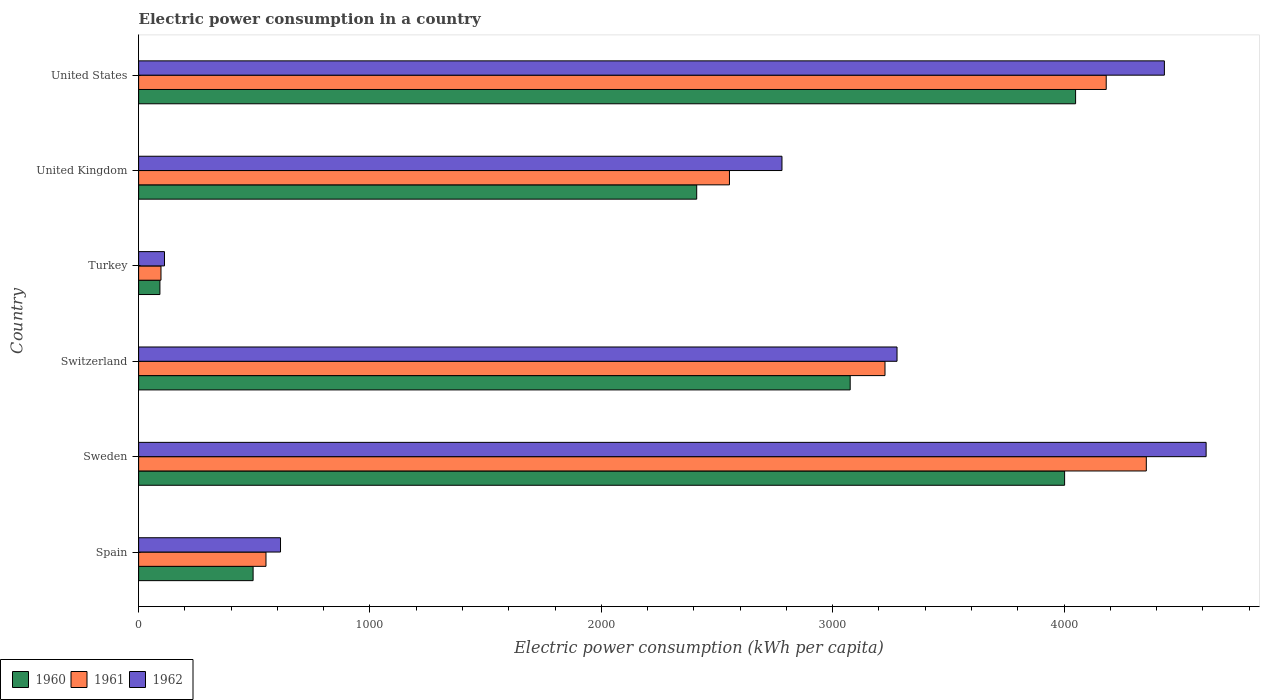How many different coloured bars are there?
Provide a succinct answer. 3. What is the electric power consumption in in 1960 in Sweden?
Give a very brief answer. 4002.32. Across all countries, what is the maximum electric power consumption in in 1961?
Your answer should be compact. 4355.45. Across all countries, what is the minimum electric power consumption in in 1961?
Give a very brief answer. 96.64. In which country was the electric power consumption in in 1962 maximum?
Your response must be concise. Sweden. In which country was the electric power consumption in in 1962 minimum?
Your answer should be compact. Turkey. What is the total electric power consumption in in 1961 in the graph?
Your answer should be very brief. 1.50e+04. What is the difference between the electric power consumption in in 1961 in Switzerland and that in United States?
Offer a very short reply. -956.18. What is the difference between the electric power consumption in in 1961 in Spain and the electric power consumption in in 1962 in Turkey?
Offer a terse response. 438.68. What is the average electric power consumption in in 1961 per country?
Your response must be concise. 2494.06. What is the difference between the electric power consumption in in 1960 and electric power consumption in in 1961 in Sweden?
Offer a very short reply. -353.13. In how many countries, is the electric power consumption in in 1960 greater than 600 kWh per capita?
Give a very brief answer. 4. What is the ratio of the electric power consumption in in 1960 in Sweden to that in United States?
Offer a terse response. 0.99. Is the electric power consumption in in 1961 in United Kingdom less than that in United States?
Your answer should be very brief. Yes. What is the difference between the highest and the second highest electric power consumption in in 1962?
Your answer should be very brief. 180.37. What is the difference between the highest and the lowest electric power consumption in in 1962?
Make the answer very short. 4502.22. In how many countries, is the electric power consumption in in 1961 greater than the average electric power consumption in in 1961 taken over all countries?
Provide a succinct answer. 4. What does the 2nd bar from the top in United States represents?
Give a very brief answer. 1961. Is it the case that in every country, the sum of the electric power consumption in in 1962 and electric power consumption in in 1961 is greater than the electric power consumption in in 1960?
Keep it short and to the point. Yes. Are all the bars in the graph horizontal?
Provide a short and direct response. Yes. Are the values on the major ticks of X-axis written in scientific E-notation?
Offer a very short reply. No. Where does the legend appear in the graph?
Ensure brevity in your answer.  Bottom left. How many legend labels are there?
Your answer should be compact. 3. How are the legend labels stacked?
Provide a short and direct response. Horizontal. What is the title of the graph?
Your answer should be very brief. Electric power consumption in a country. What is the label or title of the X-axis?
Offer a very short reply. Electric power consumption (kWh per capita). What is the label or title of the Y-axis?
Give a very brief answer. Country. What is the Electric power consumption (kWh per capita) in 1960 in Spain?
Provide a succinct answer. 494.8. What is the Electric power consumption (kWh per capita) of 1961 in Spain?
Your answer should be compact. 550.44. What is the Electric power consumption (kWh per capita) of 1962 in Spain?
Offer a very short reply. 613.25. What is the Electric power consumption (kWh per capita) in 1960 in Sweden?
Keep it short and to the point. 4002.32. What is the Electric power consumption (kWh per capita) in 1961 in Sweden?
Keep it short and to the point. 4355.45. What is the Electric power consumption (kWh per capita) of 1962 in Sweden?
Your answer should be compact. 4613.98. What is the Electric power consumption (kWh per capita) of 1960 in Switzerland?
Keep it short and to the point. 3075.55. What is the Electric power consumption (kWh per capita) in 1961 in Switzerland?
Your answer should be very brief. 3225.99. What is the Electric power consumption (kWh per capita) in 1962 in Switzerland?
Offer a terse response. 3278.01. What is the Electric power consumption (kWh per capita) of 1960 in Turkey?
Offer a terse response. 92.04. What is the Electric power consumption (kWh per capita) of 1961 in Turkey?
Ensure brevity in your answer.  96.64. What is the Electric power consumption (kWh per capita) in 1962 in Turkey?
Your answer should be compact. 111.76. What is the Electric power consumption (kWh per capita) of 1960 in United Kingdom?
Offer a terse response. 2412.14. What is the Electric power consumption (kWh per capita) in 1961 in United Kingdom?
Give a very brief answer. 2553.69. What is the Electric power consumption (kWh per capita) of 1962 in United Kingdom?
Make the answer very short. 2780.66. What is the Electric power consumption (kWh per capita) of 1960 in United States?
Offer a very short reply. 4049.79. What is the Electric power consumption (kWh per capita) in 1961 in United States?
Keep it short and to the point. 4182.18. What is the Electric power consumption (kWh per capita) of 1962 in United States?
Offer a terse response. 4433.61. Across all countries, what is the maximum Electric power consumption (kWh per capita) of 1960?
Make the answer very short. 4049.79. Across all countries, what is the maximum Electric power consumption (kWh per capita) of 1961?
Make the answer very short. 4355.45. Across all countries, what is the maximum Electric power consumption (kWh per capita) of 1962?
Offer a very short reply. 4613.98. Across all countries, what is the minimum Electric power consumption (kWh per capita) of 1960?
Give a very brief answer. 92.04. Across all countries, what is the minimum Electric power consumption (kWh per capita) in 1961?
Ensure brevity in your answer.  96.64. Across all countries, what is the minimum Electric power consumption (kWh per capita) in 1962?
Make the answer very short. 111.76. What is the total Electric power consumption (kWh per capita) of 1960 in the graph?
Your answer should be compact. 1.41e+04. What is the total Electric power consumption (kWh per capita) of 1961 in the graph?
Give a very brief answer. 1.50e+04. What is the total Electric power consumption (kWh per capita) in 1962 in the graph?
Your response must be concise. 1.58e+04. What is the difference between the Electric power consumption (kWh per capita) in 1960 in Spain and that in Sweden?
Offer a very short reply. -3507.53. What is the difference between the Electric power consumption (kWh per capita) in 1961 in Spain and that in Sweden?
Provide a succinct answer. -3805.02. What is the difference between the Electric power consumption (kWh per capita) in 1962 in Spain and that in Sweden?
Keep it short and to the point. -4000.73. What is the difference between the Electric power consumption (kWh per capita) of 1960 in Spain and that in Switzerland?
Your answer should be very brief. -2580.75. What is the difference between the Electric power consumption (kWh per capita) of 1961 in Spain and that in Switzerland?
Your answer should be very brief. -2675.56. What is the difference between the Electric power consumption (kWh per capita) in 1962 in Spain and that in Switzerland?
Your response must be concise. -2664.76. What is the difference between the Electric power consumption (kWh per capita) of 1960 in Spain and that in Turkey?
Make the answer very short. 402.76. What is the difference between the Electric power consumption (kWh per capita) of 1961 in Spain and that in Turkey?
Keep it short and to the point. 453.8. What is the difference between the Electric power consumption (kWh per capita) in 1962 in Spain and that in Turkey?
Your response must be concise. 501.49. What is the difference between the Electric power consumption (kWh per capita) in 1960 in Spain and that in United Kingdom?
Your answer should be compact. -1917.34. What is the difference between the Electric power consumption (kWh per capita) in 1961 in Spain and that in United Kingdom?
Your answer should be compact. -2003.26. What is the difference between the Electric power consumption (kWh per capita) in 1962 in Spain and that in United Kingdom?
Provide a short and direct response. -2167.41. What is the difference between the Electric power consumption (kWh per capita) of 1960 in Spain and that in United States?
Ensure brevity in your answer.  -3554.99. What is the difference between the Electric power consumption (kWh per capita) in 1961 in Spain and that in United States?
Give a very brief answer. -3631.74. What is the difference between the Electric power consumption (kWh per capita) in 1962 in Spain and that in United States?
Offer a terse response. -3820.36. What is the difference between the Electric power consumption (kWh per capita) of 1960 in Sweden and that in Switzerland?
Your answer should be compact. 926.77. What is the difference between the Electric power consumption (kWh per capita) of 1961 in Sweden and that in Switzerland?
Your answer should be compact. 1129.46. What is the difference between the Electric power consumption (kWh per capita) in 1962 in Sweden and that in Switzerland?
Ensure brevity in your answer.  1335.97. What is the difference between the Electric power consumption (kWh per capita) in 1960 in Sweden and that in Turkey?
Your answer should be compact. 3910.28. What is the difference between the Electric power consumption (kWh per capita) of 1961 in Sweden and that in Turkey?
Provide a succinct answer. 4258.82. What is the difference between the Electric power consumption (kWh per capita) in 1962 in Sweden and that in Turkey?
Provide a succinct answer. 4502.22. What is the difference between the Electric power consumption (kWh per capita) in 1960 in Sweden and that in United Kingdom?
Offer a terse response. 1590.18. What is the difference between the Electric power consumption (kWh per capita) in 1961 in Sweden and that in United Kingdom?
Provide a short and direct response. 1801.76. What is the difference between the Electric power consumption (kWh per capita) of 1962 in Sweden and that in United Kingdom?
Offer a very short reply. 1833.32. What is the difference between the Electric power consumption (kWh per capita) in 1960 in Sweden and that in United States?
Your response must be concise. -47.47. What is the difference between the Electric power consumption (kWh per capita) in 1961 in Sweden and that in United States?
Offer a terse response. 173.28. What is the difference between the Electric power consumption (kWh per capita) of 1962 in Sweden and that in United States?
Give a very brief answer. 180.37. What is the difference between the Electric power consumption (kWh per capita) in 1960 in Switzerland and that in Turkey?
Provide a short and direct response. 2983.51. What is the difference between the Electric power consumption (kWh per capita) of 1961 in Switzerland and that in Turkey?
Offer a terse response. 3129.36. What is the difference between the Electric power consumption (kWh per capita) in 1962 in Switzerland and that in Turkey?
Offer a terse response. 3166.25. What is the difference between the Electric power consumption (kWh per capita) in 1960 in Switzerland and that in United Kingdom?
Provide a succinct answer. 663.41. What is the difference between the Electric power consumption (kWh per capita) in 1961 in Switzerland and that in United Kingdom?
Offer a very short reply. 672.3. What is the difference between the Electric power consumption (kWh per capita) of 1962 in Switzerland and that in United Kingdom?
Your response must be concise. 497.35. What is the difference between the Electric power consumption (kWh per capita) in 1960 in Switzerland and that in United States?
Give a very brief answer. -974.24. What is the difference between the Electric power consumption (kWh per capita) in 1961 in Switzerland and that in United States?
Your response must be concise. -956.18. What is the difference between the Electric power consumption (kWh per capita) of 1962 in Switzerland and that in United States?
Offer a terse response. -1155.6. What is the difference between the Electric power consumption (kWh per capita) in 1960 in Turkey and that in United Kingdom?
Provide a succinct answer. -2320.1. What is the difference between the Electric power consumption (kWh per capita) of 1961 in Turkey and that in United Kingdom?
Ensure brevity in your answer.  -2457.06. What is the difference between the Electric power consumption (kWh per capita) of 1962 in Turkey and that in United Kingdom?
Offer a very short reply. -2668.9. What is the difference between the Electric power consumption (kWh per capita) of 1960 in Turkey and that in United States?
Offer a very short reply. -3957.75. What is the difference between the Electric power consumption (kWh per capita) in 1961 in Turkey and that in United States?
Keep it short and to the point. -4085.54. What is the difference between the Electric power consumption (kWh per capita) of 1962 in Turkey and that in United States?
Ensure brevity in your answer.  -4321.85. What is the difference between the Electric power consumption (kWh per capita) in 1960 in United Kingdom and that in United States?
Provide a short and direct response. -1637.65. What is the difference between the Electric power consumption (kWh per capita) in 1961 in United Kingdom and that in United States?
Your answer should be compact. -1628.48. What is the difference between the Electric power consumption (kWh per capita) of 1962 in United Kingdom and that in United States?
Offer a very short reply. -1652.95. What is the difference between the Electric power consumption (kWh per capita) in 1960 in Spain and the Electric power consumption (kWh per capita) in 1961 in Sweden?
Offer a very short reply. -3860.66. What is the difference between the Electric power consumption (kWh per capita) in 1960 in Spain and the Electric power consumption (kWh per capita) in 1962 in Sweden?
Ensure brevity in your answer.  -4119.18. What is the difference between the Electric power consumption (kWh per capita) in 1961 in Spain and the Electric power consumption (kWh per capita) in 1962 in Sweden?
Give a very brief answer. -4063.54. What is the difference between the Electric power consumption (kWh per capita) of 1960 in Spain and the Electric power consumption (kWh per capita) of 1961 in Switzerland?
Your response must be concise. -2731.2. What is the difference between the Electric power consumption (kWh per capita) in 1960 in Spain and the Electric power consumption (kWh per capita) in 1962 in Switzerland?
Make the answer very short. -2783.21. What is the difference between the Electric power consumption (kWh per capita) of 1961 in Spain and the Electric power consumption (kWh per capita) of 1962 in Switzerland?
Offer a very short reply. -2727.57. What is the difference between the Electric power consumption (kWh per capita) in 1960 in Spain and the Electric power consumption (kWh per capita) in 1961 in Turkey?
Make the answer very short. 398.16. What is the difference between the Electric power consumption (kWh per capita) of 1960 in Spain and the Electric power consumption (kWh per capita) of 1962 in Turkey?
Give a very brief answer. 383.03. What is the difference between the Electric power consumption (kWh per capita) of 1961 in Spain and the Electric power consumption (kWh per capita) of 1962 in Turkey?
Your answer should be compact. 438.68. What is the difference between the Electric power consumption (kWh per capita) in 1960 in Spain and the Electric power consumption (kWh per capita) in 1961 in United Kingdom?
Provide a succinct answer. -2058.9. What is the difference between the Electric power consumption (kWh per capita) in 1960 in Spain and the Electric power consumption (kWh per capita) in 1962 in United Kingdom?
Provide a succinct answer. -2285.86. What is the difference between the Electric power consumption (kWh per capita) in 1961 in Spain and the Electric power consumption (kWh per capita) in 1962 in United Kingdom?
Your answer should be very brief. -2230.22. What is the difference between the Electric power consumption (kWh per capita) in 1960 in Spain and the Electric power consumption (kWh per capita) in 1961 in United States?
Provide a short and direct response. -3687.38. What is the difference between the Electric power consumption (kWh per capita) in 1960 in Spain and the Electric power consumption (kWh per capita) in 1962 in United States?
Make the answer very short. -3938.81. What is the difference between the Electric power consumption (kWh per capita) in 1961 in Spain and the Electric power consumption (kWh per capita) in 1962 in United States?
Offer a terse response. -3883.17. What is the difference between the Electric power consumption (kWh per capita) in 1960 in Sweden and the Electric power consumption (kWh per capita) in 1961 in Switzerland?
Keep it short and to the point. 776.33. What is the difference between the Electric power consumption (kWh per capita) of 1960 in Sweden and the Electric power consumption (kWh per capita) of 1962 in Switzerland?
Your answer should be compact. 724.32. What is the difference between the Electric power consumption (kWh per capita) of 1961 in Sweden and the Electric power consumption (kWh per capita) of 1962 in Switzerland?
Your answer should be compact. 1077.45. What is the difference between the Electric power consumption (kWh per capita) in 1960 in Sweden and the Electric power consumption (kWh per capita) in 1961 in Turkey?
Your answer should be very brief. 3905.68. What is the difference between the Electric power consumption (kWh per capita) of 1960 in Sweden and the Electric power consumption (kWh per capita) of 1962 in Turkey?
Your answer should be very brief. 3890.56. What is the difference between the Electric power consumption (kWh per capita) of 1961 in Sweden and the Electric power consumption (kWh per capita) of 1962 in Turkey?
Offer a very short reply. 4243.69. What is the difference between the Electric power consumption (kWh per capita) of 1960 in Sweden and the Electric power consumption (kWh per capita) of 1961 in United Kingdom?
Provide a succinct answer. 1448.63. What is the difference between the Electric power consumption (kWh per capita) in 1960 in Sweden and the Electric power consumption (kWh per capita) in 1962 in United Kingdom?
Your answer should be very brief. 1221.66. What is the difference between the Electric power consumption (kWh per capita) of 1961 in Sweden and the Electric power consumption (kWh per capita) of 1962 in United Kingdom?
Offer a terse response. 1574.8. What is the difference between the Electric power consumption (kWh per capita) of 1960 in Sweden and the Electric power consumption (kWh per capita) of 1961 in United States?
Your answer should be very brief. -179.85. What is the difference between the Electric power consumption (kWh per capita) of 1960 in Sweden and the Electric power consumption (kWh per capita) of 1962 in United States?
Offer a terse response. -431.28. What is the difference between the Electric power consumption (kWh per capita) in 1961 in Sweden and the Electric power consumption (kWh per capita) in 1962 in United States?
Give a very brief answer. -78.15. What is the difference between the Electric power consumption (kWh per capita) in 1960 in Switzerland and the Electric power consumption (kWh per capita) in 1961 in Turkey?
Offer a very short reply. 2978.91. What is the difference between the Electric power consumption (kWh per capita) in 1960 in Switzerland and the Electric power consumption (kWh per capita) in 1962 in Turkey?
Provide a short and direct response. 2963.79. What is the difference between the Electric power consumption (kWh per capita) in 1961 in Switzerland and the Electric power consumption (kWh per capita) in 1962 in Turkey?
Ensure brevity in your answer.  3114.23. What is the difference between the Electric power consumption (kWh per capita) in 1960 in Switzerland and the Electric power consumption (kWh per capita) in 1961 in United Kingdom?
Your answer should be compact. 521.86. What is the difference between the Electric power consumption (kWh per capita) in 1960 in Switzerland and the Electric power consumption (kWh per capita) in 1962 in United Kingdom?
Offer a terse response. 294.89. What is the difference between the Electric power consumption (kWh per capita) of 1961 in Switzerland and the Electric power consumption (kWh per capita) of 1962 in United Kingdom?
Ensure brevity in your answer.  445.34. What is the difference between the Electric power consumption (kWh per capita) in 1960 in Switzerland and the Electric power consumption (kWh per capita) in 1961 in United States?
Give a very brief answer. -1106.63. What is the difference between the Electric power consumption (kWh per capita) in 1960 in Switzerland and the Electric power consumption (kWh per capita) in 1962 in United States?
Ensure brevity in your answer.  -1358.06. What is the difference between the Electric power consumption (kWh per capita) in 1961 in Switzerland and the Electric power consumption (kWh per capita) in 1962 in United States?
Your response must be concise. -1207.61. What is the difference between the Electric power consumption (kWh per capita) of 1960 in Turkey and the Electric power consumption (kWh per capita) of 1961 in United Kingdom?
Your answer should be compact. -2461.65. What is the difference between the Electric power consumption (kWh per capita) in 1960 in Turkey and the Electric power consumption (kWh per capita) in 1962 in United Kingdom?
Provide a short and direct response. -2688.62. What is the difference between the Electric power consumption (kWh per capita) in 1961 in Turkey and the Electric power consumption (kWh per capita) in 1962 in United Kingdom?
Your answer should be compact. -2684.02. What is the difference between the Electric power consumption (kWh per capita) in 1960 in Turkey and the Electric power consumption (kWh per capita) in 1961 in United States?
Your answer should be very brief. -4090.14. What is the difference between the Electric power consumption (kWh per capita) of 1960 in Turkey and the Electric power consumption (kWh per capita) of 1962 in United States?
Offer a terse response. -4341.57. What is the difference between the Electric power consumption (kWh per capita) of 1961 in Turkey and the Electric power consumption (kWh per capita) of 1962 in United States?
Your answer should be compact. -4336.97. What is the difference between the Electric power consumption (kWh per capita) in 1960 in United Kingdom and the Electric power consumption (kWh per capita) in 1961 in United States?
Your response must be concise. -1770.04. What is the difference between the Electric power consumption (kWh per capita) in 1960 in United Kingdom and the Electric power consumption (kWh per capita) in 1962 in United States?
Offer a terse response. -2021.47. What is the difference between the Electric power consumption (kWh per capita) of 1961 in United Kingdom and the Electric power consumption (kWh per capita) of 1962 in United States?
Make the answer very short. -1879.91. What is the average Electric power consumption (kWh per capita) in 1960 per country?
Offer a very short reply. 2354.44. What is the average Electric power consumption (kWh per capita) in 1961 per country?
Your answer should be compact. 2494.06. What is the average Electric power consumption (kWh per capita) of 1962 per country?
Ensure brevity in your answer.  2638.54. What is the difference between the Electric power consumption (kWh per capita) of 1960 and Electric power consumption (kWh per capita) of 1961 in Spain?
Keep it short and to the point. -55.64. What is the difference between the Electric power consumption (kWh per capita) in 1960 and Electric power consumption (kWh per capita) in 1962 in Spain?
Offer a very short reply. -118.45. What is the difference between the Electric power consumption (kWh per capita) of 1961 and Electric power consumption (kWh per capita) of 1962 in Spain?
Provide a short and direct response. -62.81. What is the difference between the Electric power consumption (kWh per capita) of 1960 and Electric power consumption (kWh per capita) of 1961 in Sweden?
Offer a terse response. -353.13. What is the difference between the Electric power consumption (kWh per capita) in 1960 and Electric power consumption (kWh per capita) in 1962 in Sweden?
Offer a terse response. -611.66. What is the difference between the Electric power consumption (kWh per capita) in 1961 and Electric power consumption (kWh per capita) in 1962 in Sweden?
Ensure brevity in your answer.  -258.52. What is the difference between the Electric power consumption (kWh per capita) in 1960 and Electric power consumption (kWh per capita) in 1961 in Switzerland?
Offer a very short reply. -150.44. What is the difference between the Electric power consumption (kWh per capita) of 1960 and Electric power consumption (kWh per capita) of 1962 in Switzerland?
Ensure brevity in your answer.  -202.46. What is the difference between the Electric power consumption (kWh per capita) in 1961 and Electric power consumption (kWh per capita) in 1962 in Switzerland?
Your answer should be compact. -52.01. What is the difference between the Electric power consumption (kWh per capita) in 1960 and Electric power consumption (kWh per capita) in 1961 in Turkey?
Offer a terse response. -4.6. What is the difference between the Electric power consumption (kWh per capita) in 1960 and Electric power consumption (kWh per capita) in 1962 in Turkey?
Your answer should be compact. -19.72. What is the difference between the Electric power consumption (kWh per capita) in 1961 and Electric power consumption (kWh per capita) in 1962 in Turkey?
Your answer should be compact. -15.12. What is the difference between the Electric power consumption (kWh per capita) in 1960 and Electric power consumption (kWh per capita) in 1961 in United Kingdom?
Give a very brief answer. -141.56. What is the difference between the Electric power consumption (kWh per capita) of 1960 and Electric power consumption (kWh per capita) of 1962 in United Kingdom?
Provide a short and direct response. -368.52. What is the difference between the Electric power consumption (kWh per capita) of 1961 and Electric power consumption (kWh per capita) of 1962 in United Kingdom?
Offer a terse response. -226.96. What is the difference between the Electric power consumption (kWh per capita) in 1960 and Electric power consumption (kWh per capita) in 1961 in United States?
Provide a short and direct response. -132.39. What is the difference between the Electric power consumption (kWh per capita) of 1960 and Electric power consumption (kWh per capita) of 1962 in United States?
Your answer should be compact. -383.82. What is the difference between the Electric power consumption (kWh per capita) of 1961 and Electric power consumption (kWh per capita) of 1962 in United States?
Offer a very short reply. -251.43. What is the ratio of the Electric power consumption (kWh per capita) in 1960 in Spain to that in Sweden?
Offer a very short reply. 0.12. What is the ratio of the Electric power consumption (kWh per capita) in 1961 in Spain to that in Sweden?
Offer a very short reply. 0.13. What is the ratio of the Electric power consumption (kWh per capita) in 1962 in Spain to that in Sweden?
Offer a terse response. 0.13. What is the ratio of the Electric power consumption (kWh per capita) of 1960 in Spain to that in Switzerland?
Offer a terse response. 0.16. What is the ratio of the Electric power consumption (kWh per capita) of 1961 in Spain to that in Switzerland?
Your answer should be compact. 0.17. What is the ratio of the Electric power consumption (kWh per capita) in 1962 in Spain to that in Switzerland?
Provide a short and direct response. 0.19. What is the ratio of the Electric power consumption (kWh per capita) in 1960 in Spain to that in Turkey?
Offer a very short reply. 5.38. What is the ratio of the Electric power consumption (kWh per capita) in 1961 in Spain to that in Turkey?
Your answer should be very brief. 5.7. What is the ratio of the Electric power consumption (kWh per capita) of 1962 in Spain to that in Turkey?
Give a very brief answer. 5.49. What is the ratio of the Electric power consumption (kWh per capita) in 1960 in Spain to that in United Kingdom?
Offer a terse response. 0.21. What is the ratio of the Electric power consumption (kWh per capita) in 1961 in Spain to that in United Kingdom?
Offer a terse response. 0.22. What is the ratio of the Electric power consumption (kWh per capita) of 1962 in Spain to that in United Kingdom?
Offer a terse response. 0.22. What is the ratio of the Electric power consumption (kWh per capita) in 1960 in Spain to that in United States?
Keep it short and to the point. 0.12. What is the ratio of the Electric power consumption (kWh per capita) of 1961 in Spain to that in United States?
Make the answer very short. 0.13. What is the ratio of the Electric power consumption (kWh per capita) of 1962 in Spain to that in United States?
Make the answer very short. 0.14. What is the ratio of the Electric power consumption (kWh per capita) of 1960 in Sweden to that in Switzerland?
Give a very brief answer. 1.3. What is the ratio of the Electric power consumption (kWh per capita) of 1961 in Sweden to that in Switzerland?
Offer a very short reply. 1.35. What is the ratio of the Electric power consumption (kWh per capita) of 1962 in Sweden to that in Switzerland?
Provide a succinct answer. 1.41. What is the ratio of the Electric power consumption (kWh per capita) in 1960 in Sweden to that in Turkey?
Ensure brevity in your answer.  43.48. What is the ratio of the Electric power consumption (kWh per capita) in 1961 in Sweden to that in Turkey?
Your answer should be very brief. 45.07. What is the ratio of the Electric power consumption (kWh per capita) of 1962 in Sweden to that in Turkey?
Keep it short and to the point. 41.28. What is the ratio of the Electric power consumption (kWh per capita) in 1960 in Sweden to that in United Kingdom?
Offer a very short reply. 1.66. What is the ratio of the Electric power consumption (kWh per capita) of 1961 in Sweden to that in United Kingdom?
Keep it short and to the point. 1.71. What is the ratio of the Electric power consumption (kWh per capita) in 1962 in Sweden to that in United Kingdom?
Ensure brevity in your answer.  1.66. What is the ratio of the Electric power consumption (kWh per capita) in 1960 in Sweden to that in United States?
Your answer should be very brief. 0.99. What is the ratio of the Electric power consumption (kWh per capita) of 1961 in Sweden to that in United States?
Provide a succinct answer. 1.04. What is the ratio of the Electric power consumption (kWh per capita) in 1962 in Sweden to that in United States?
Provide a succinct answer. 1.04. What is the ratio of the Electric power consumption (kWh per capita) of 1960 in Switzerland to that in Turkey?
Make the answer very short. 33.42. What is the ratio of the Electric power consumption (kWh per capita) in 1961 in Switzerland to that in Turkey?
Provide a succinct answer. 33.38. What is the ratio of the Electric power consumption (kWh per capita) of 1962 in Switzerland to that in Turkey?
Your answer should be very brief. 29.33. What is the ratio of the Electric power consumption (kWh per capita) of 1960 in Switzerland to that in United Kingdom?
Provide a succinct answer. 1.27. What is the ratio of the Electric power consumption (kWh per capita) of 1961 in Switzerland to that in United Kingdom?
Your response must be concise. 1.26. What is the ratio of the Electric power consumption (kWh per capita) in 1962 in Switzerland to that in United Kingdom?
Keep it short and to the point. 1.18. What is the ratio of the Electric power consumption (kWh per capita) in 1960 in Switzerland to that in United States?
Provide a short and direct response. 0.76. What is the ratio of the Electric power consumption (kWh per capita) in 1961 in Switzerland to that in United States?
Provide a succinct answer. 0.77. What is the ratio of the Electric power consumption (kWh per capita) in 1962 in Switzerland to that in United States?
Your answer should be very brief. 0.74. What is the ratio of the Electric power consumption (kWh per capita) of 1960 in Turkey to that in United Kingdom?
Keep it short and to the point. 0.04. What is the ratio of the Electric power consumption (kWh per capita) in 1961 in Turkey to that in United Kingdom?
Offer a terse response. 0.04. What is the ratio of the Electric power consumption (kWh per capita) of 1962 in Turkey to that in United Kingdom?
Keep it short and to the point. 0.04. What is the ratio of the Electric power consumption (kWh per capita) in 1960 in Turkey to that in United States?
Keep it short and to the point. 0.02. What is the ratio of the Electric power consumption (kWh per capita) in 1961 in Turkey to that in United States?
Keep it short and to the point. 0.02. What is the ratio of the Electric power consumption (kWh per capita) of 1962 in Turkey to that in United States?
Your response must be concise. 0.03. What is the ratio of the Electric power consumption (kWh per capita) in 1960 in United Kingdom to that in United States?
Provide a short and direct response. 0.6. What is the ratio of the Electric power consumption (kWh per capita) of 1961 in United Kingdom to that in United States?
Your answer should be compact. 0.61. What is the ratio of the Electric power consumption (kWh per capita) in 1962 in United Kingdom to that in United States?
Provide a short and direct response. 0.63. What is the difference between the highest and the second highest Electric power consumption (kWh per capita) in 1960?
Give a very brief answer. 47.47. What is the difference between the highest and the second highest Electric power consumption (kWh per capita) in 1961?
Provide a short and direct response. 173.28. What is the difference between the highest and the second highest Electric power consumption (kWh per capita) in 1962?
Offer a terse response. 180.37. What is the difference between the highest and the lowest Electric power consumption (kWh per capita) in 1960?
Provide a short and direct response. 3957.75. What is the difference between the highest and the lowest Electric power consumption (kWh per capita) of 1961?
Offer a very short reply. 4258.82. What is the difference between the highest and the lowest Electric power consumption (kWh per capita) in 1962?
Make the answer very short. 4502.22. 